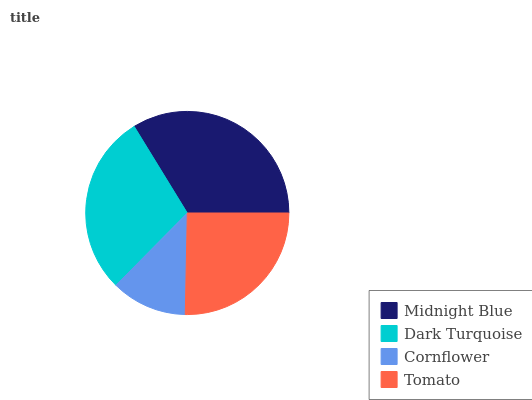Is Cornflower the minimum?
Answer yes or no. Yes. Is Midnight Blue the maximum?
Answer yes or no. Yes. Is Dark Turquoise the minimum?
Answer yes or no. No. Is Dark Turquoise the maximum?
Answer yes or no. No. Is Midnight Blue greater than Dark Turquoise?
Answer yes or no. Yes. Is Dark Turquoise less than Midnight Blue?
Answer yes or no. Yes. Is Dark Turquoise greater than Midnight Blue?
Answer yes or no. No. Is Midnight Blue less than Dark Turquoise?
Answer yes or no. No. Is Dark Turquoise the high median?
Answer yes or no. Yes. Is Tomato the low median?
Answer yes or no. Yes. Is Cornflower the high median?
Answer yes or no. No. Is Midnight Blue the low median?
Answer yes or no. No. 